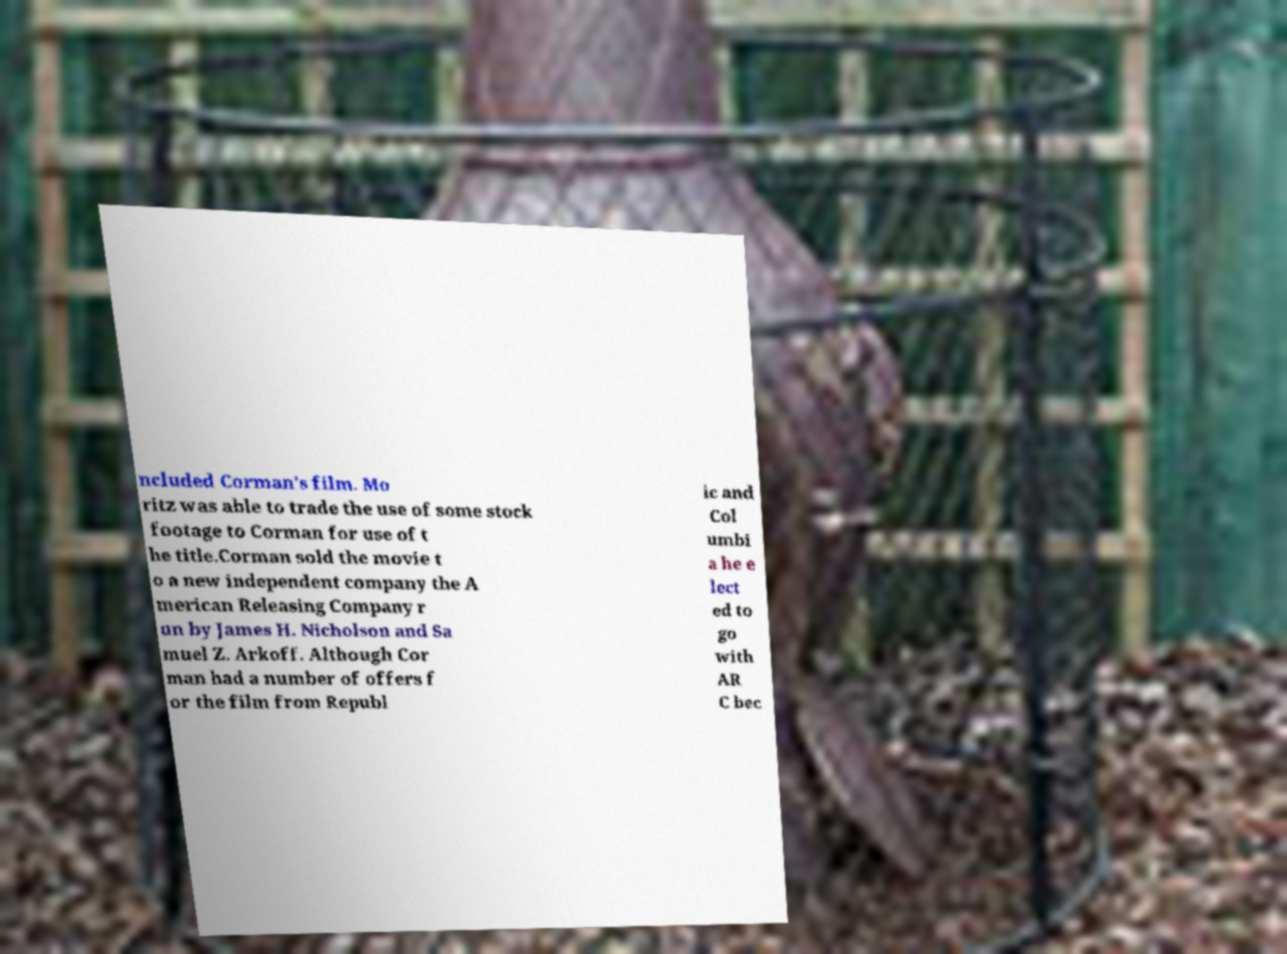Can you read and provide the text displayed in the image?This photo seems to have some interesting text. Can you extract and type it out for me? ncluded Corman's film. Mo ritz was able to trade the use of some stock footage to Corman for use of t he title.Corman sold the movie t o a new independent company the A merican Releasing Company r un by James H. Nicholson and Sa muel Z. Arkoff. Although Cor man had a number of offers f or the film from Republ ic and Col umbi a he e lect ed to go with AR C bec 